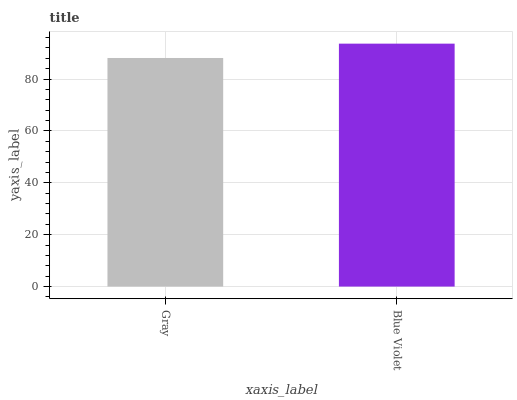Is Gray the minimum?
Answer yes or no. Yes. Is Blue Violet the maximum?
Answer yes or no. Yes. Is Blue Violet the minimum?
Answer yes or no. No. Is Blue Violet greater than Gray?
Answer yes or no. Yes. Is Gray less than Blue Violet?
Answer yes or no. Yes. Is Gray greater than Blue Violet?
Answer yes or no. No. Is Blue Violet less than Gray?
Answer yes or no. No. Is Blue Violet the high median?
Answer yes or no. Yes. Is Gray the low median?
Answer yes or no. Yes. Is Gray the high median?
Answer yes or no. No. Is Blue Violet the low median?
Answer yes or no. No. 